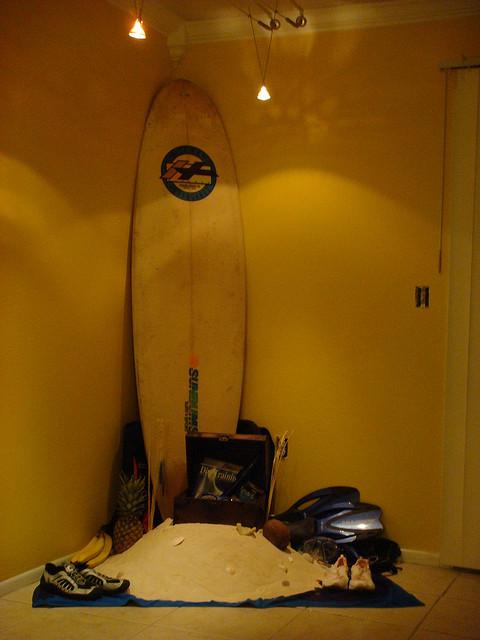Is the surfboard wet?
Keep it brief. No. What kind of lighting is in this room?
Give a very brief answer. Soft. Is someone wearing the shoes?
Short answer required. No. Is there fruit in the beach scene?
Keep it brief. Yes. Who does the doll belong to?
Keep it brief. No one. 